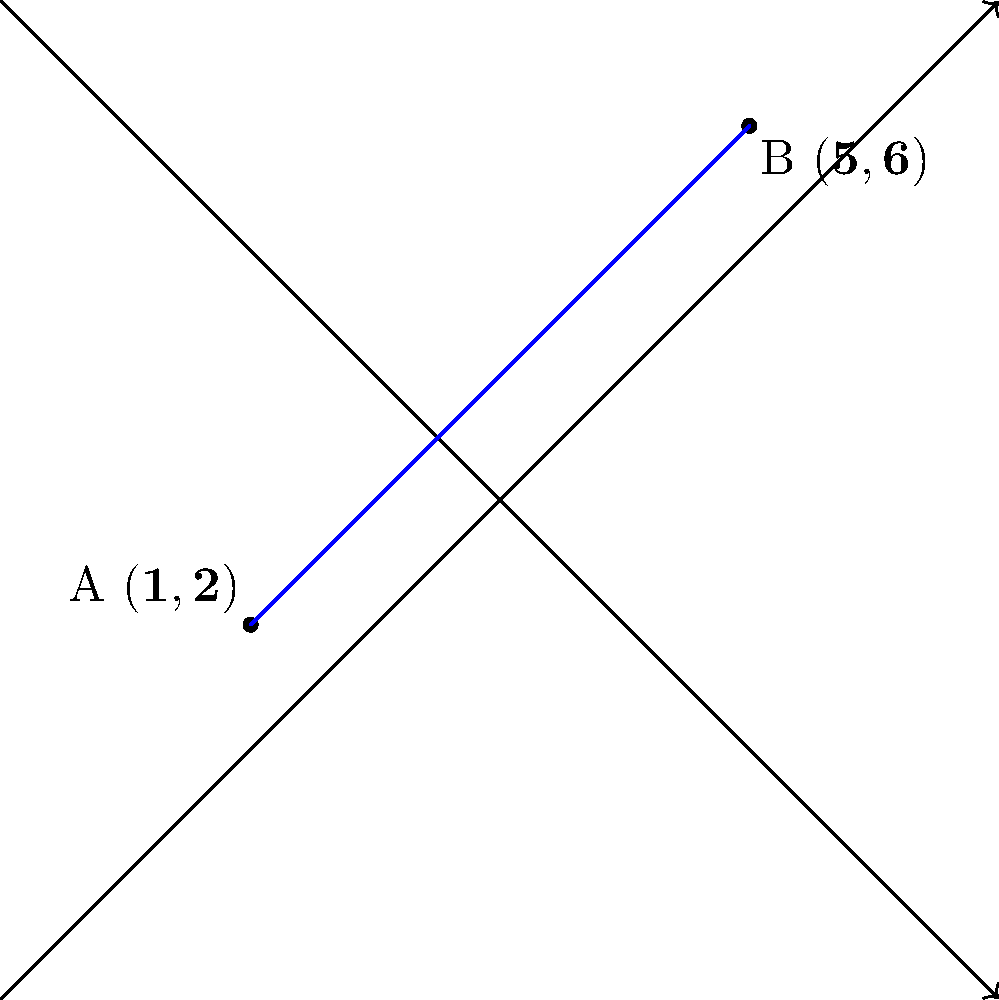In a digital illustration, you need to precisely place two objects on a coordinate plane. The first object is at point A (1,2) and the second object is at point B (5,6). Calculate the exact distance between these two points to ensure accurate placement in your artwork. To find the distance between two points on a coordinate plane, we can use the distance formula, which is derived from the Pythagorean theorem:

$$d = \sqrt{(x_2 - x_1)^2 + (y_2 - y_1)^2}$$

Where $(x_1, y_1)$ are the coordinates of the first point and $(x_2, y_2)$ are the coordinates of the second point.

Given:
Point A: $(x_1, y_1) = (1, 2)$
Point B: $(x_2, y_2) = (5, 6)$

Let's plug these values into the formula:

$$d = \sqrt{(5 - 1)^2 + (6 - 2)^2}$$

Simplify:
$$d = \sqrt{4^2 + 4^2}$$
$$d = \sqrt{16 + 16}$$
$$d = \sqrt{32}$$

Simplify the square root:
$$d = 4\sqrt{2}$$

Therefore, the exact distance between points A and B is $4\sqrt{2}$ units.
Answer: $4\sqrt{2}$ units 